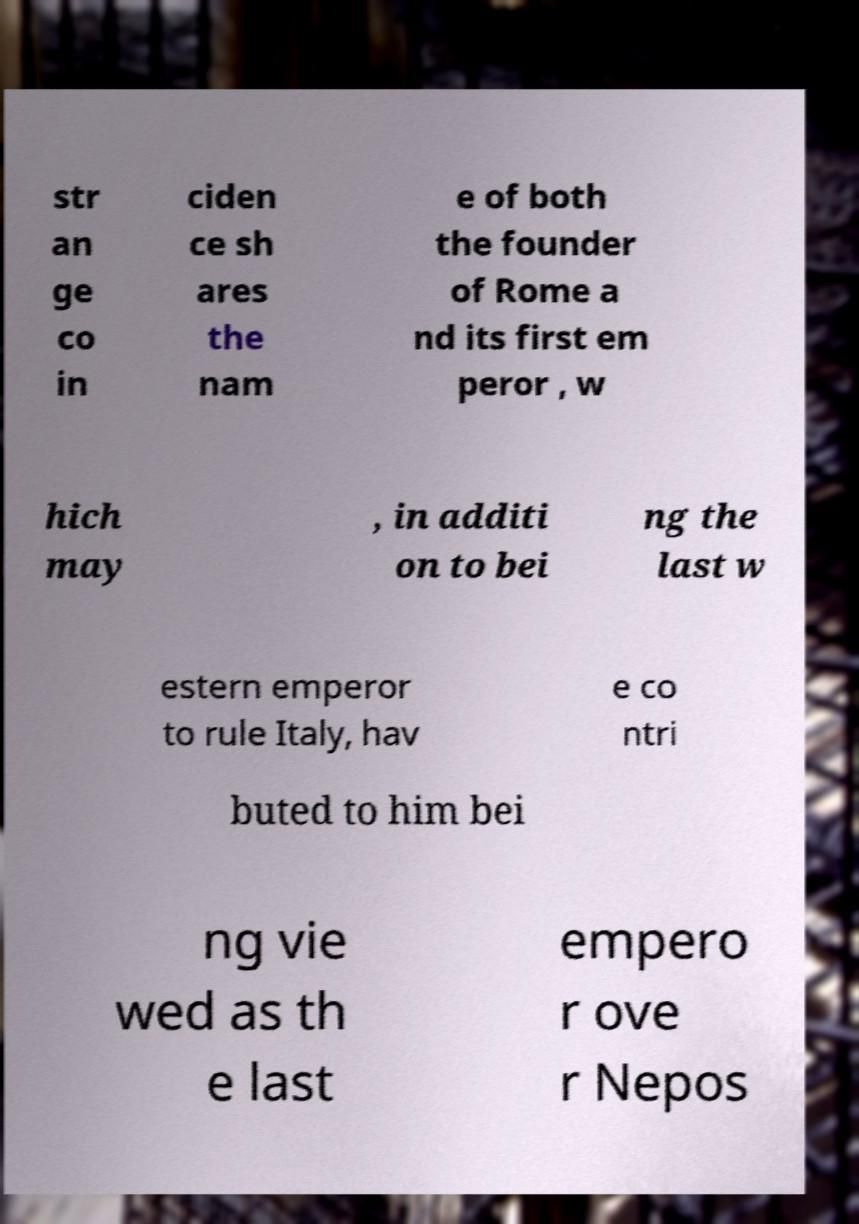Please identify and transcribe the text found in this image. str an ge co in ciden ce sh ares the nam e of both the founder of Rome a nd its first em peror , w hich may , in additi on to bei ng the last w estern emperor to rule Italy, hav e co ntri buted to him bei ng vie wed as th e last empero r ove r Nepos 